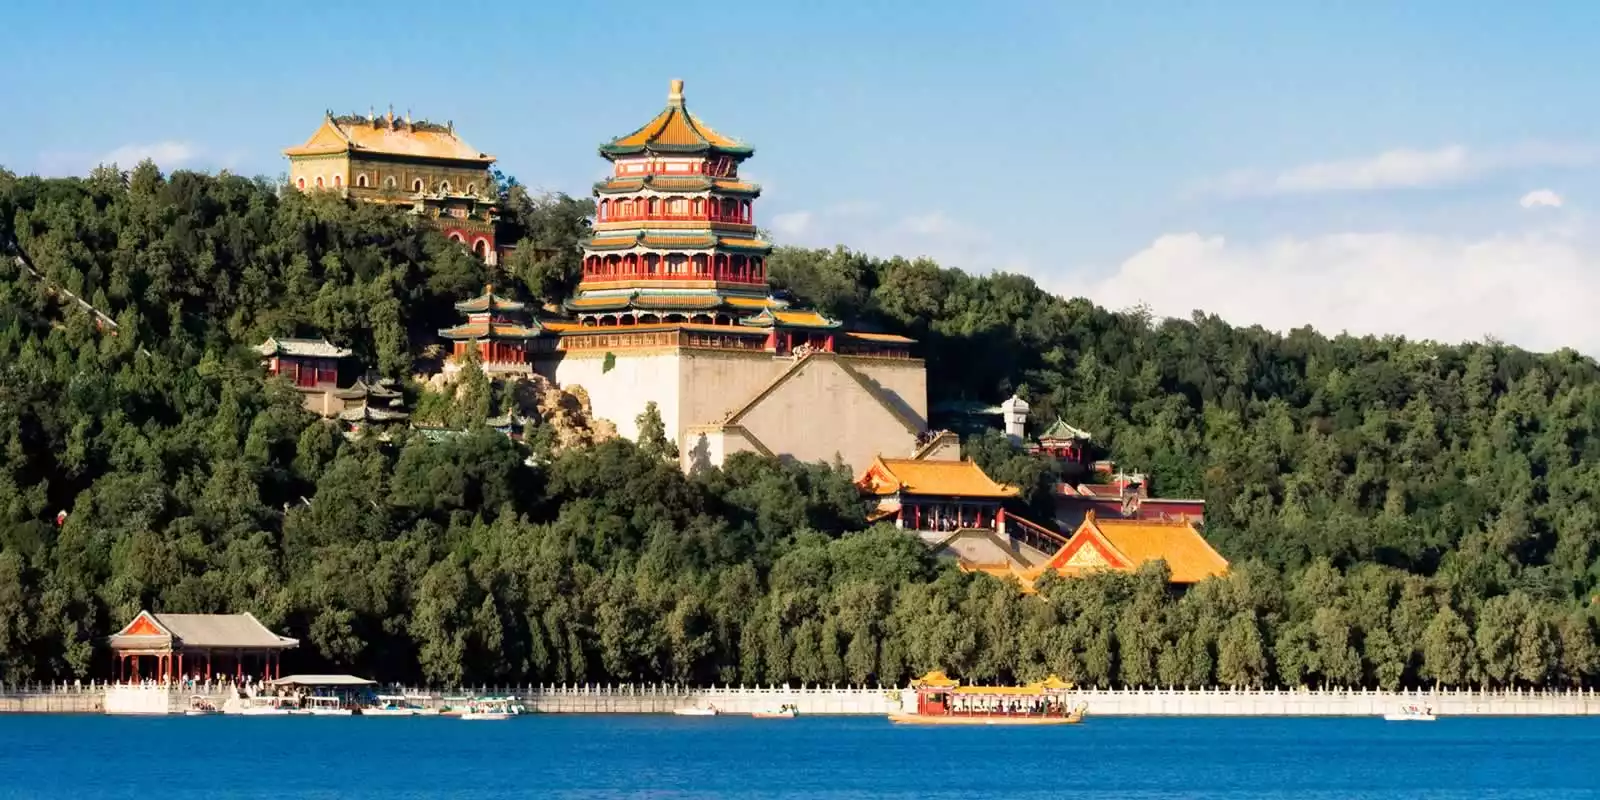What stories do the architectural styles of the Summer Palace tell us? The architectural styles of the Summer Palace weave a rich tapestry of China's imperial history and aesthetic philosophies. The vibrant colors and intricate designs reflect the heights of Chinese craftsmanship. The prominent Tower of Buddhist Incense, with its octagonal base and multi-tiered eaves, mirrors the Buddhist influence and the emperors' devotion to spiritual practices. The elaborate pavilions and halls scattered throughout the grounds exemplify architectural harmony with nature, adhering to the Chinese principle of balancing built structures with the natural environment. Each building within the palace tells a story of imperial grandeur, religious devotion, and a deep-seated appreciation for natural beauty. These elements collectively narrate the tale of a place that served not just as a regal residence, but as a spiritual and cultural haven. 